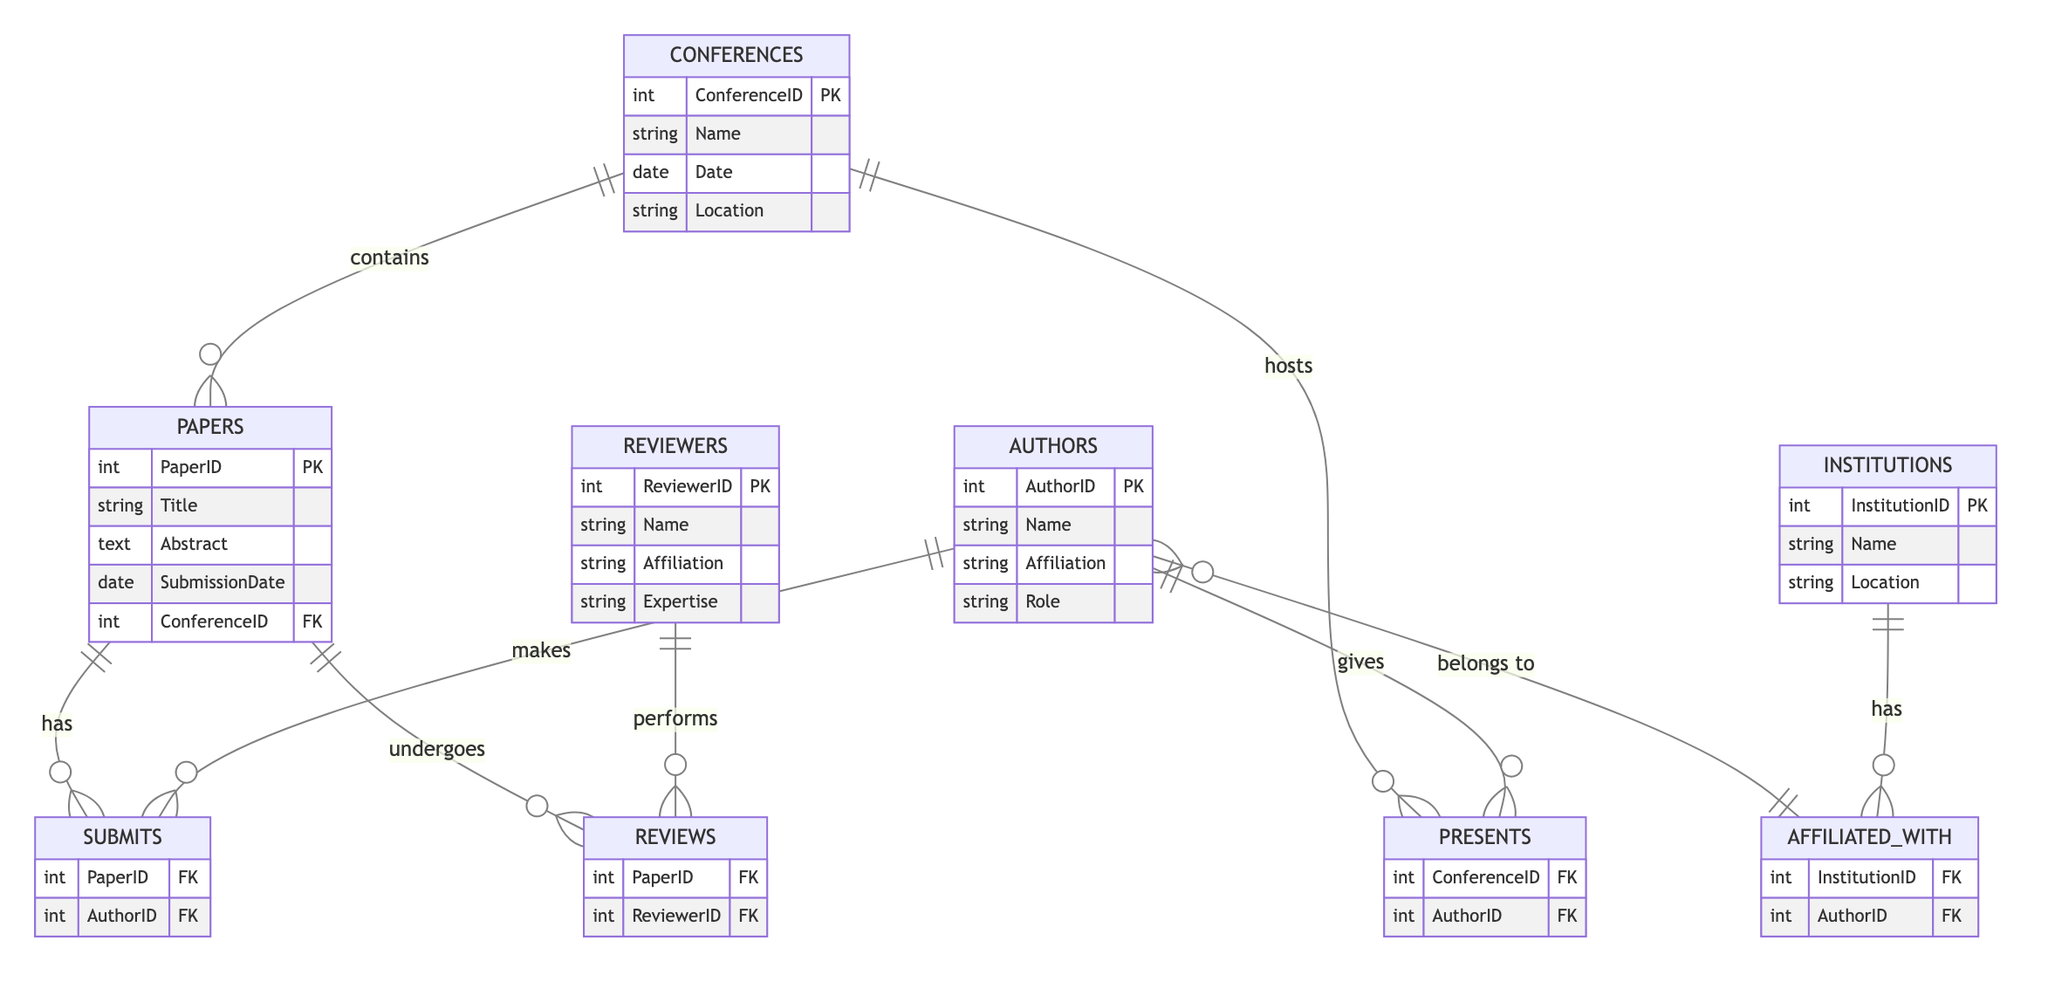What's the primary key of the Conferences entity? The primary key for the Conferences entity is ConferenceID, which uniquely identifies conference records in the database. It is established in the diagram under the Conferences entity section.
Answer: ConferenceID How many entities are represented in the diagram? The diagram includes five entities: Conferences, Papers, Authors, Reviewers, and Institutions. This can be counted directly by identifying the labeled sections in the diagram.
Answer: Five What relationship exists between Authors and Papers? The relationship between Authors and Papers is represented by the "submits" relationship, indicating that authors submit papers in the context of this ER diagram. This can be seen from the connecting line labeled "makes" that connects the Authors entity to the Submits relationship, which in turn connects to the Papers entity.
Answer: submits Which entity is related to the Reviews relationship? The Reviews relationship is related to the Papers and Reviewers entities, which can be identified by tracing the relationship from Reviews to both Papers and Reviewers in the ER diagram.
Answer: Papers and Reviewers How many authors can present at a conference according to the diagram? Multiple authors can present at a conference, as indicated by the "hosts" relationship between Conferences and Presenters which allows for many authors to present at one conference. Each author linked through the Presents relationship can be counted as a potential presenter at the conference.
Answer: Many Which entity would you check to find out the expertise of a reviewer? You would check the Reviewers entity to find out information about their expertise, as this entity specifically includes an Expertise attribute that describes the reviewer’s area of knowledge.
Answer: Reviewers How many relationships connect Authors to Institutions? There is one specific relationship called "affiliated_with" that connects Authors to Institutions, indicating that authors are associated with their respective institutions. This can be verified by looking for the line labeled "has" that joins these two entities in the diagram.
Answer: One What does the connection labeled "undergoes" signify in the diagram? The connection labeled "undergoes" signifies that Papers undergo reviews, indicating a process where submitted papers are evaluated by reviewers. This relationship can be identified from the direct link stemming from the Papers entity to the Reviews relationship.
Answer: Reviews What is the role of an author within the context of a paper? The role of an author within the context of a paper is outlined in the Authors entity where the "Role" attribute specifies the responsibilities or titles that the author holds, which can be directly referenced from the Authors entity in the diagram.
Answer: Role 